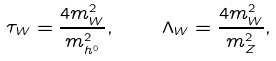Convert formula to latex. <formula><loc_0><loc_0><loc_500><loc_500>\tau _ { W } = \frac { 4 m _ { W } ^ { 2 } } { m _ { h ^ { 0 } } ^ { 2 } } , \quad \Lambda _ { W } = \frac { 4 m _ { W } ^ { 2 } } { m _ { Z } ^ { 2 } } ,</formula> 